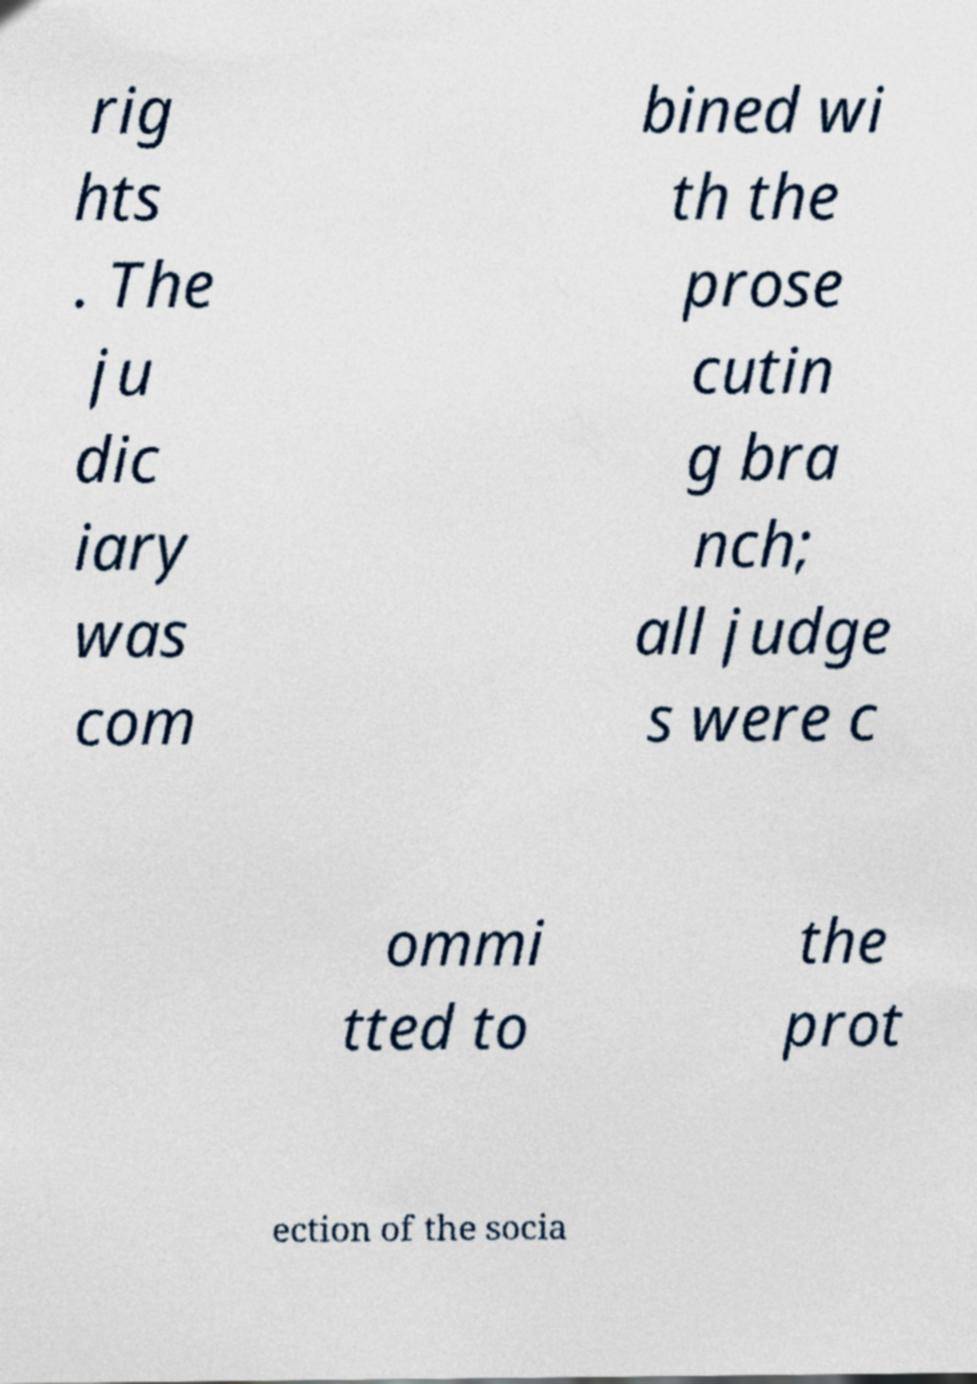Please identify and transcribe the text found in this image. rig hts . The ju dic iary was com bined wi th the prose cutin g bra nch; all judge s were c ommi tted to the prot ection of the socia 